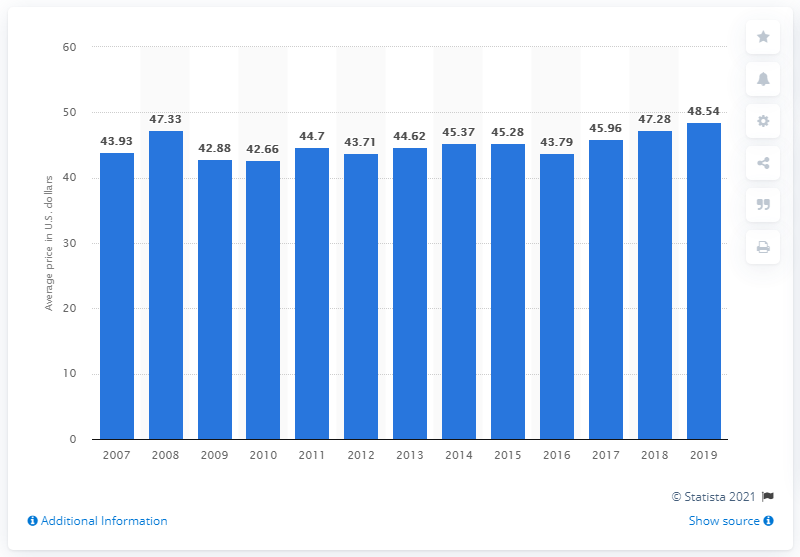Specify some key components in this picture. In 2019, the average price for a deluxe pedicure in the United States was $48.54. 